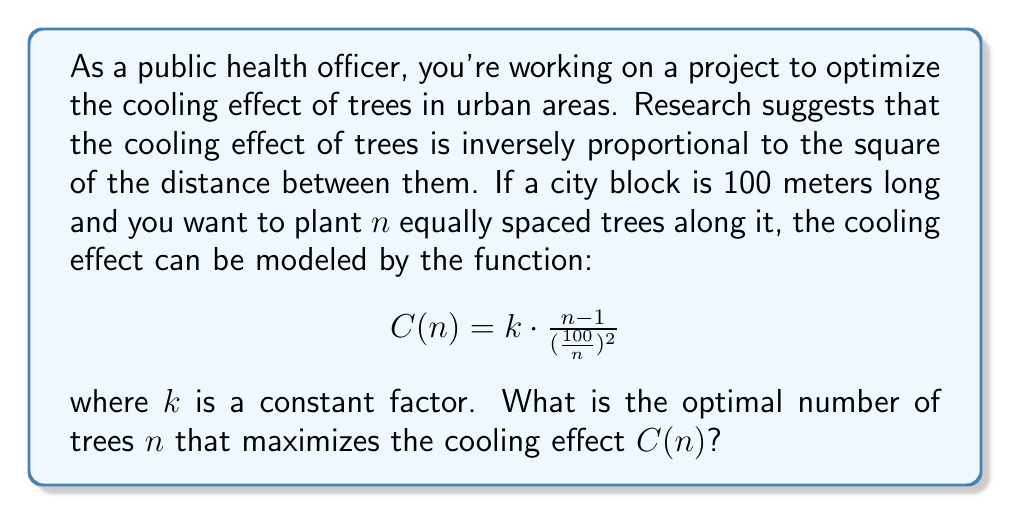Provide a solution to this math problem. To find the optimal number of trees, we need to maximize the function $C(n)$. We can do this by finding the derivative of $C(n)$ with respect to $n$, setting it equal to zero, and solving for $n$.

1) First, let's simplify the function:
   $$C(n) = k \cdot \frac{n-1}{(\frac{100}{n})^2} = k \cdot \frac{n-1}{10000} \cdot n^2 = \frac{k}{10000}(n^3 - n^2)$$

2) Now, let's find the derivative:
   $$C'(n) = \frac{k}{10000}(3n^2 - 2n)$$

3) Set this equal to zero and solve:
   $$\frac{k}{10000}(3n^2 - 2n) = 0$$
   $$3n^2 - 2n = 0$$
   $$n(3n - 2) = 0$$

4) Solving this equation:
   $n = 0$ or $3n - 2 = 0$
   $n = 0$ or $n = \frac{2}{3}$

5) Since $n$ represents the number of trees, it must be a positive integer. The solution $n = 0$ doesn't make sense in this context, and $n = \frac{2}{3}$ isn't an integer.

6) To find the integer solution, we need to check the values of $C(n)$ for the integers around $\frac{2}{3}$, which are 1 and 2:

   For $n = 1$: $C(1) = \frac{k}{10000}(1^3 - 1^2) = 0$
   For $n = 2$: $C(2) = \frac{k}{10000}(2^3 - 2^2) = \frac{4k}{10000}$

7) Therefore, the optimal integer value for $n$ is 2.
Answer: The optimal number of trees to maximize the cooling effect is 2. 